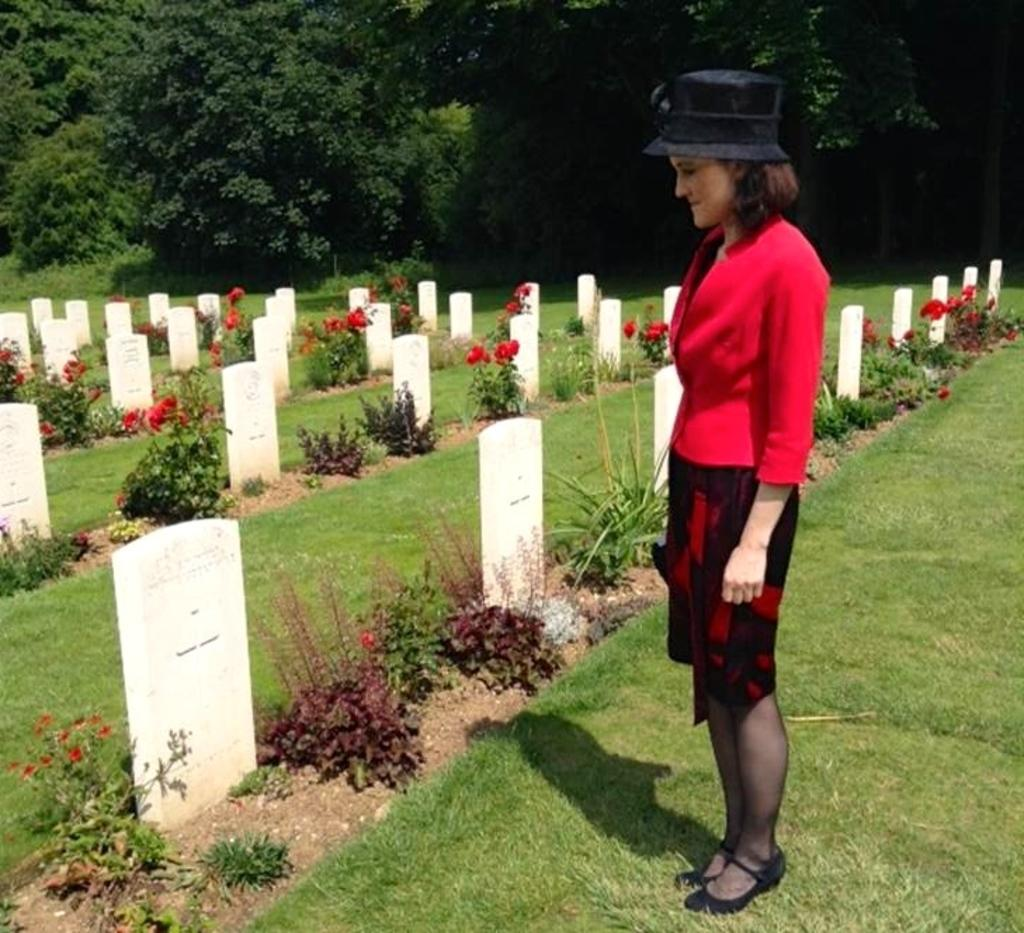Who is the main subject in the image? There is a lady in the image. What is the lady wearing? The lady is wearing a red and black color dress and a hat. What type of vegetation can be seen in the image? There are plants, grass, red color flowers, and trees in the image. What is the setting of the image? The image appears to be in a cemetery, as there are graves present. What type of meat is being served at the children's party in the image? There is no children's party or meat present in the image. What type of stone is used to build the monument in the image? There is no monument or stone present in the image. 